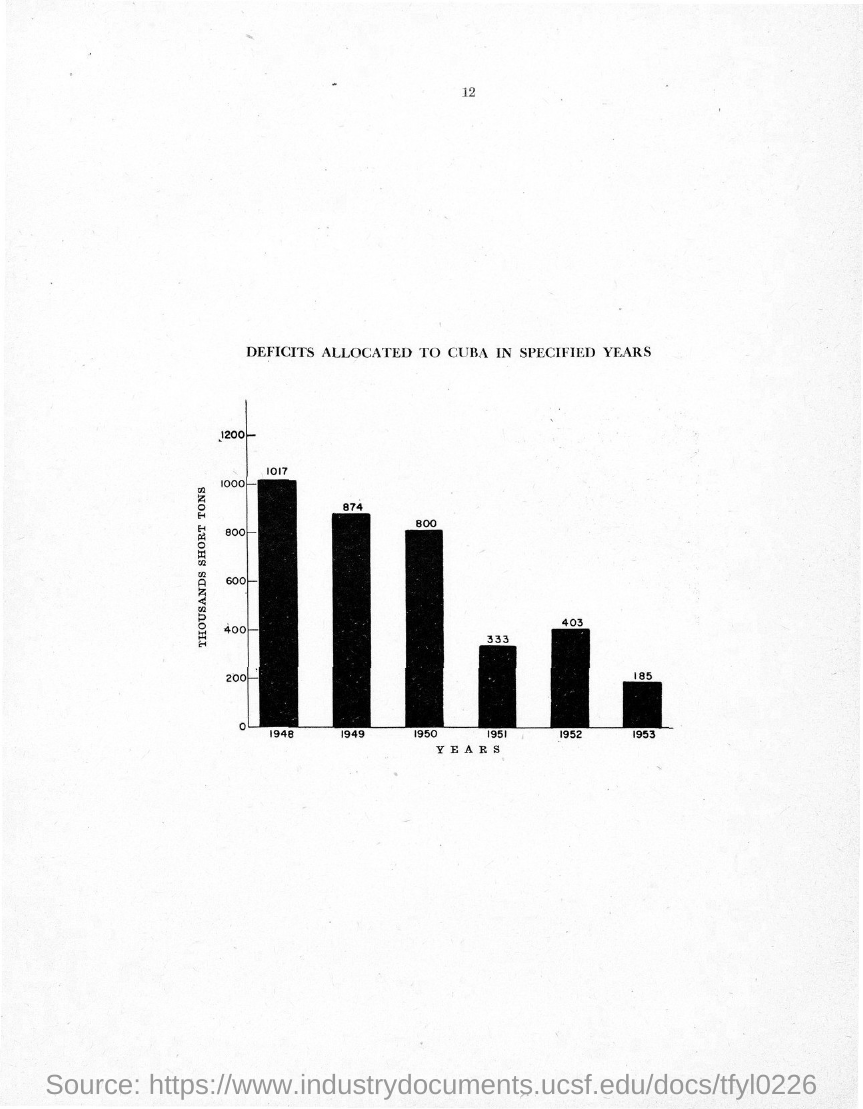What is the title of the graph shown?
Offer a terse response. DEFICITS ALLOCATED TO CUBA IN SPECIFIED YEARS. What is the page no mentioned in this document?
Ensure brevity in your answer.  12. What does x-axis of the graph represent?
Your answer should be compact. YEARS. What does y-axis of the graph represent?
Ensure brevity in your answer.  THOUSANDS SHORT TONS. 